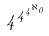<formula> <loc_0><loc_0><loc_500><loc_500>4 ^ { 4 ^ { 4 ^ { \aleph _ { 0 } } } }</formula> 